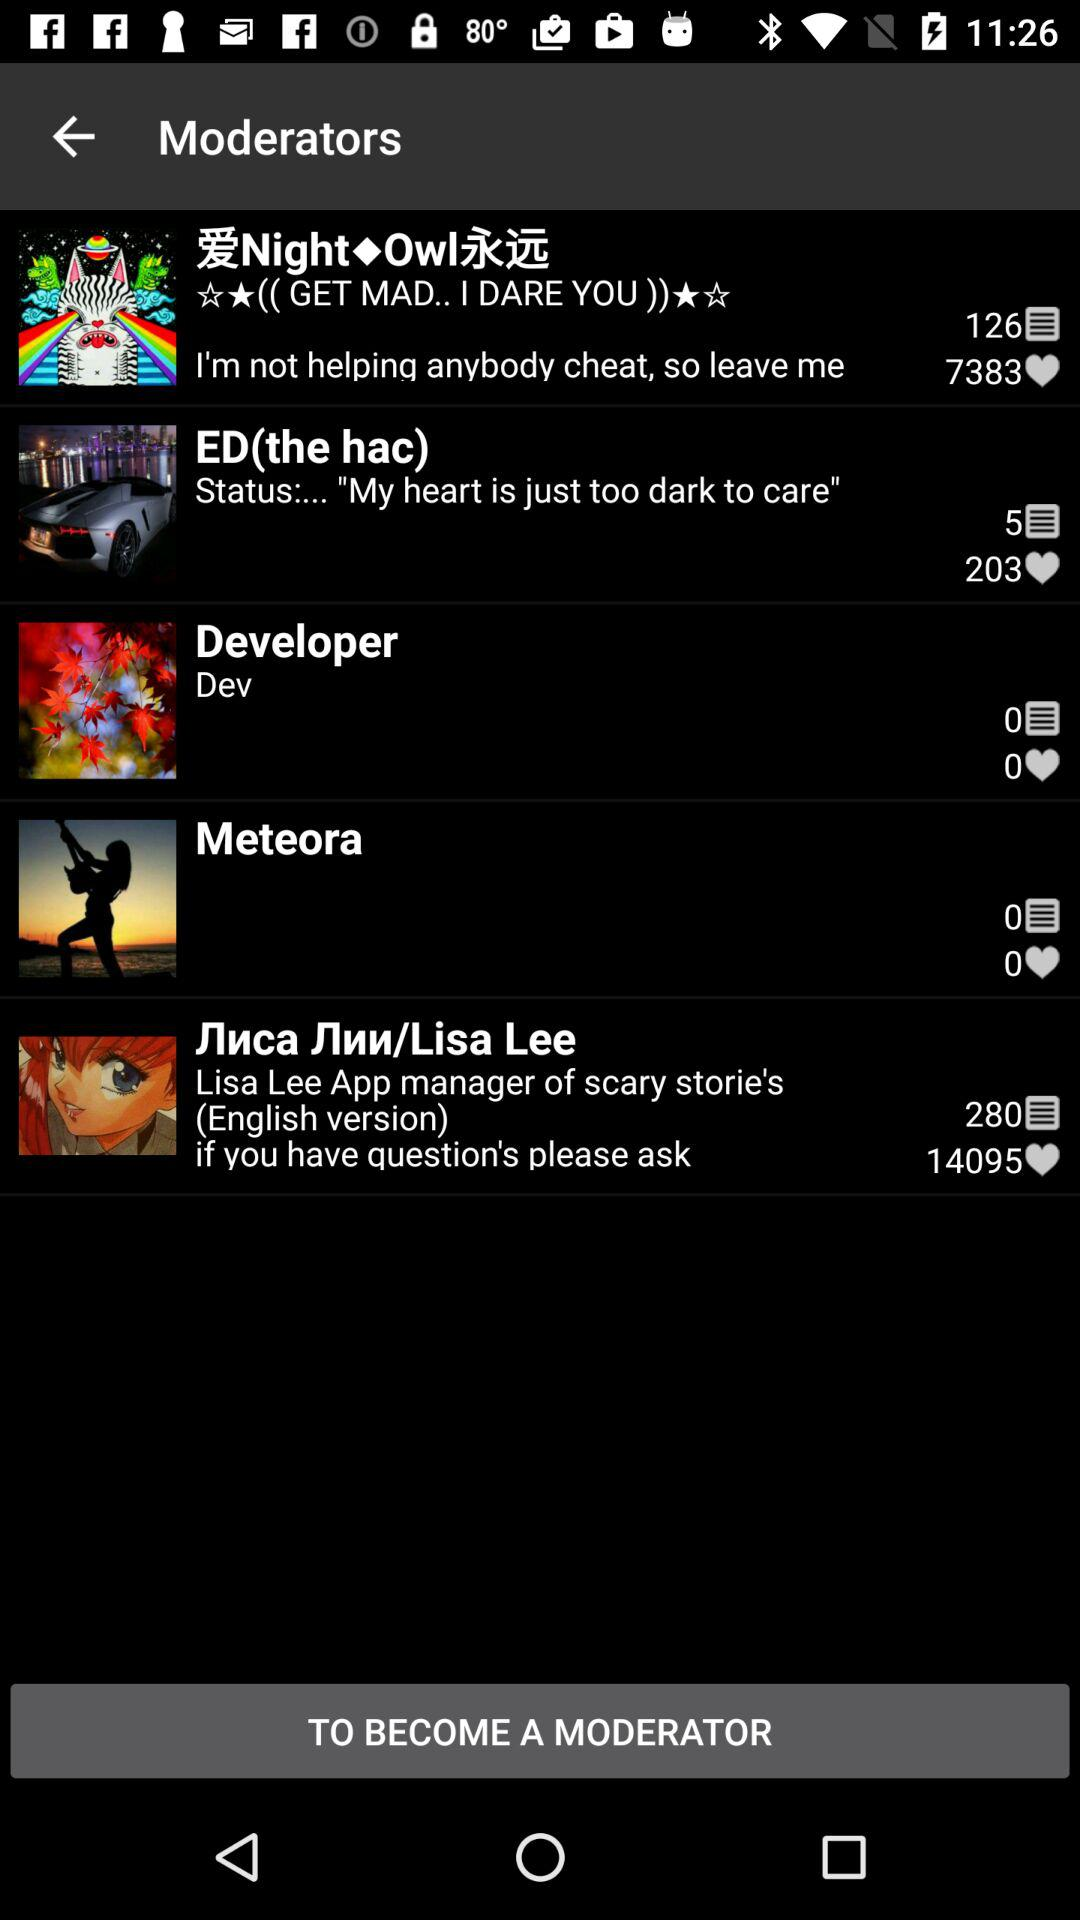What is the number of likes in "Meteora"? The number of likes in "Meteora" is 0. 